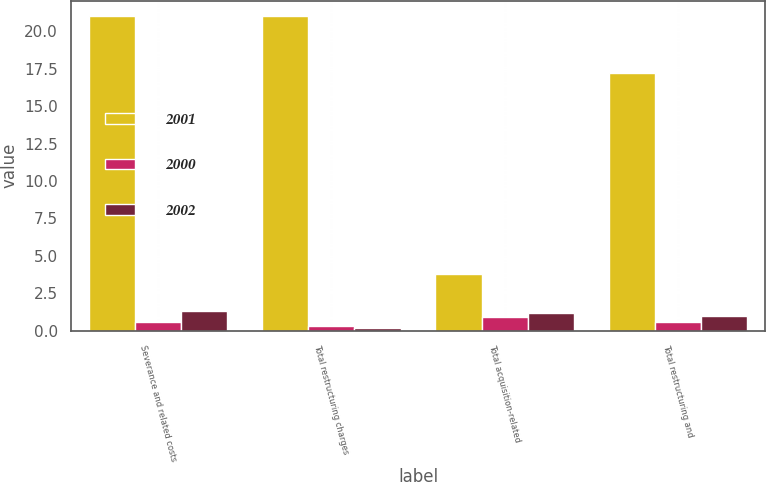Convert chart to OTSL. <chart><loc_0><loc_0><loc_500><loc_500><stacked_bar_chart><ecel><fcel>Severance and related costs<fcel>Total restructuring charges<fcel>Total acquisition-related<fcel>Total restructuring and<nl><fcel>2001<fcel>21<fcel>21<fcel>3.8<fcel>17.2<nl><fcel>2000<fcel>0.6<fcel>0.3<fcel>0.9<fcel>0.6<nl><fcel>2002<fcel>1.3<fcel>0.2<fcel>1.2<fcel>1<nl></chart> 